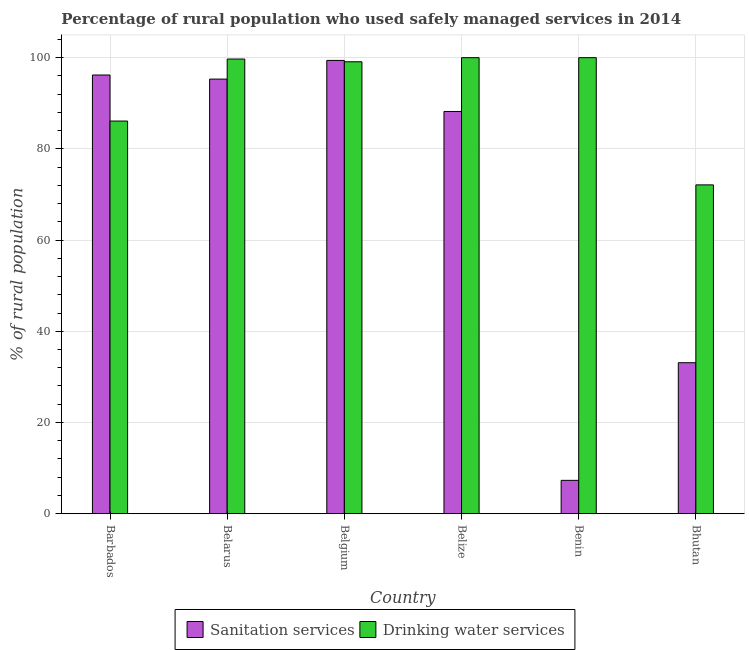How many groups of bars are there?
Ensure brevity in your answer.  6. Are the number of bars per tick equal to the number of legend labels?
Offer a terse response. Yes. How many bars are there on the 1st tick from the left?
Keep it short and to the point. 2. What is the label of the 1st group of bars from the left?
Your response must be concise. Barbados. In how many cases, is the number of bars for a given country not equal to the number of legend labels?
Offer a terse response. 0. What is the percentage of rural population who used sanitation services in Barbados?
Your answer should be compact. 96.2. Across all countries, what is the maximum percentage of rural population who used sanitation services?
Your answer should be very brief. 99.4. In which country was the percentage of rural population who used drinking water services maximum?
Your answer should be compact. Belize. In which country was the percentage of rural population who used sanitation services minimum?
Your response must be concise. Benin. What is the total percentage of rural population who used sanitation services in the graph?
Give a very brief answer. 419.5. What is the difference between the percentage of rural population who used drinking water services in Belarus and that in Benin?
Ensure brevity in your answer.  -0.3. What is the difference between the percentage of rural population who used drinking water services in Bhutan and the percentage of rural population who used sanitation services in Barbados?
Give a very brief answer. -24.1. What is the average percentage of rural population who used drinking water services per country?
Your answer should be very brief. 92.83. What is the difference between the percentage of rural population who used sanitation services and percentage of rural population who used drinking water services in Barbados?
Offer a terse response. 10.1. What is the ratio of the percentage of rural population who used sanitation services in Belgium to that in Benin?
Make the answer very short. 13.62. Is the percentage of rural population who used drinking water services in Belgium less than that in Belize?
Ensure brevity in your answer.  Yes. Is the difference between the percentage of rural population who used drinking water services in Belize and Bhutan greater than the difference between the percentage of rural population who used sanitation services in Belize and Bhutan?
Your answer should be compact. No. What is the difference between the highest and the second highest percentage of rural population who used sanitation services?
Give a very brief answer. 3.2. What is the difference between the highest and the lowest percentage of rural population who used drinking water services?
Your answer should be compact. 27.9. What does the 2nd bar from the left in Bhutan represents?
Your answer should be compact. Drinking water services. What does the 1st bar from the right in Barbados represents?
Your response must be concise. Drinking water services. How many bars are there?
Offer a very short reply. 12. Are the values on the major ticks of Y-axis written in scientific E-notation?
Offer a very short reply. No. Does the graph contain any zero values?
Offer a terse response. No. Does the graph contain grids?
Provide a short and direct response. Yes. Where does the legend appear in the graph?
Offer a terse response. Bottom center. How are the legend labels stacked?
Your answer should be compact. Horizontal. What is the title of the graph?
Your response must be concise. Percentage of rural population who used safely managed services in 2014. Does "constant 2005 US$" appear as one of the legend labels in the graph?
Offer a terse response. No. What is the label or title of the Y-axis?
Give a very brief answer. % of rural population. What is the % of rural population in Sanitation services in Barbados?
Keep it short and to the point. 96.2. What is the % of rural population of Drinking water services in Barbados?
Make the answer very short. 86.1. What is the % of rural population in Sanitation services in Belarus?
Your response must be concise. 95.3. What is the % of rural population of Drinking water services in Belarus?
Your answer should be compact. 99.7. What is the % of rural population of Sanitation services in Belgium?
Give a very brief answer. 99.4. What is the % of rural population of Drinking water services in Belgium?
Provide a short and direct response. 99.1. What is the % of rural population in Sanitation services in Belize?
Offer a very short reply. 88.2. What is the % of rural population of Drinking water services in Belize?
Give a very brief answer. 100. What is the % of rural population of Sanitation services in Benin?
Offer a terse response. 7.3. What is the % of rural population in Drinking water services in Benin?
Offer a terse response. 100. What is the % of rural population in Sanitation services in Bhutan?
Provide a succinct answer. 33.1. What is the % of rural population in Drinking water services in Bhutan?
Offer a terse response. 72.1. Across all countries, what is the maximum % of rural population in Sanitation services?
Give a very brief answer. 99.4. Across all countries, what is the minimum % of rural population in Drinking water services?
Provide a short and direct response. 72.1. What is the total % of rural population in Sanitation services in the graph?
Keep it short and to the point. 419.5. What is the total % of rural population in Drinking water services in the graph?
Give a very brief answer. 557. What is the difference between the % of rural population in Sanitation services in Barbados and that in Belarus?
Offer a terse response. 0.9. What is the difference between the % of rural population in Sanitation services in Barbados and that in Belgium?
Your response must be concise. -3.2. What is the difference between the % of rural population of Drinking water services in Barbados and that in Belgium?
Provide a succinct answer. -13. What is the difference between the % of rural population of Drinking water services in Barbados and that in Belize?
Keep it short and to the point. -13.9. What is the difference between the % of rural population of Sanitation services in Barbados and that in Benin?
Your answer should be compact. 88.9. What is the difference between the % of rural population of Sanitation services in Barbados and that in Bhutan?
Your answer should be very brief. 63.1. What is the difference between the % of rural population in Sanitation services in Belarus and that in Belize?
Make the answer very short. 7.1. What is the difference between the % of rural population in Drinking water services in Belarus and that in Belize?
Provide a short and direct response. -0.3. What is the difference between the % of rural population of Sanitation services in Belarus and that in Bhutan?
Ensure brevity in your answer.  62.2. What is the difference between the % of rural population in Drinking water services in Belarus and that in Bhutan?
Give a very brief answer. 27.6. What is the difference between the % of rural population in Sanitation services in Belgium and that in Belize?
Give a very brief answer. 11.2. What is the difference between the % of rural population of Sanitation services in Belgium and that in Benin?
Make the answer very short. 92.1. What is the difference between the % of rural population in Drinking water services in Belgium and that in Benin?
Offer a terse response. -0.9. What is the difference between the % of rural population of Sanitation services in Belgium and that in Bhutan?
Provide a short and direct response. 66.3. What is the difference between the % of rural population in Drinking water services in Belgium and that in Bhutan?
Keep it short and to the point. 27. What is the difference between the % of rural population of Sanitation services in Belize and that in Benin?
Provide a short and direct response. 80.9. What is the difference between the % of rural population of Drinking water services in Belize and that in Benin?
Make the answer very short. 0. What is the difference between the % of rural population in Sanitation services in Belize and that in Bhutan?
Your response must be concise. 55.1. What is the difference between the % of rural population in Drinking water services in Belize and that in Bhutan?
Provide a short and direct response. 27.9. What is the difference between the % of rural population in Sanitation services in Benin and that in Bhutan?
Ensure brevity in your answer.  -25.8. What is the difference between the % of rural population in Drinking water services in Benin and that in Bhutan?
Provide a short and direct response. 27.9. What is the difference between the % of rural population in Sanitation services in Barbados and the % of rural population in Drinking water services in Belarus?
Give a very brief answer. -3.5. What is the difference between the % of rural population of Sanitation services in Barbados and the % of rural population of Drinking water services in Benin?
Make the answer very short. -3.8. What is the difference between the % of rural population of Sanitation services in Barbados and the % of rural population of Drinking water services in Bhutan?
Keep it short and to the point. 24.1. What is the difference between the % of rural population in Sanitation services in Belarus and the % of rural population in Drinking water services in Benin?
Provide a succinct answer. -4.7. What is the difference between the % of rural population in Sanitation services in Belarus and the % of rural population in Drinking water services in Bhutan?
Your response must be concise. 23.2. What is the difference between the % of rural population of Sanitation services in Belgium and the % of rural population of Drinking water services in Belize?
Offer a terse response. -0.6. What is the difference between the % of rural population of Sanitation services in Belgium and the % of rural population of Drinking water services in Benin?
Offer a very short reply. -0.6. What is the difference between the % of rural population of Sanitation services in Belgium and the % of rural population of Drinking water services in Bhutan?
Your answer should be compact. 27.3. What is the difference between the % of rural population of Sanitation services in Belize and the % of rural population of Drinking water services in Benin?
Ensure brevity in your answer.  -11.8. What is the difference between the % of rural population of Sanitation services in Benin and the % of rural population of Drinking water services in Bhutan?
Keep it short and to the point. -64.8. What is the average % of rural population of Sanitation services per country?
Your answer should be very brief. 69.92. What is the average % of rural population in Drinking water services per country?
Keep it short and to the point. 92.83. What is the difference between the % of rural population in Sanitation services and % of rural population in Drinking water services in Barbados?
Give a very brief answer. 10.1. What is the difference between the % of rural population in Sanitation services and % of rural population in Drinking water services in Belize?
Provide a succinct answer. -11.8. What is the difference between the % of rural population in Sanitation services and % of rural population in Drinking water services in Benin?
Your answer should be compact. -92.7. What is the difference between the % of rural population of Sanitation services and % of rural population of Drinking water services in Bhutan?
Your answer should be very brief. -39. What is the ratio of the % of rural population of Sanitation services in Barbados to that in Belarus?
Keep it short and to the point. 1.01. What is the ratio of the % of rural population of Drinking water services in Barbados to that in Belarus?
Make the answer very short. 0.86. What is the ratio of the % of rural population in Sanitation services in Barbados to that in Belgium?
Give a very brief answer. 0.97. What is the ratio of the % of rural population in Drinking water services in Barbados to that in Belgium?
Your response must be concise. 0.87. What is the ratio of the % of rural population in Sanitation services in Barbados to that in Belize?
Provide a short and direct response. 1.09. What is the ratio of the % of rural population in Drinking water services in Barbados to that in Belize?
Your response must be concise. 0.86. What is the ratio of the % of rural population of Sanitation services in Barbados to that in Benin?
Make the answer very short. 13.18. What is the ratio of the % of rural population of Drinking water services in Barbados to that in Benin?
Offer a terse response. 0.86. What is the ratio of the % of rural population in Sanitation services in Barbados to that in Bhutan?
Your response must be concise. 2.91. What is the ratio of the % of rural population in Drinking water services in Barbados to that in Bhutan?
Give a very brief answer. 1.19. What is the ratio of the % of rural population in Sanitation services in Belarus to that in Belgium?
Ensure brevity in your answer.  0.96. What is the ratio of the % of rural population of Drinking water services in Belarus to that in Belgium?
Your response must be concise. 1.01. What is the ratio of the % of rural population of Sanitation services in Belarus to that in Belize?
Your answer should be very brief. 1.08. What is the ratio of the % of rural population in Sanitation services in Belarus to that in Benin?
Keep it short and to the point. 13.05. What is the ratio of the % of rural population in Drinking water services in Belarus to that in Benin?
Your answer should be compact. 1. What is the ratio of the % of rural population in Sanitation services in Belarus to that in Bhutan?
Provide a short and direct response. 2.88. What is the ratio of the % of rural population of Drinking water services in Belarus to that in Bhutan?
Offer a very short reply. 1.38. What is the ratio of the % of rural population of Sanitation services in Belgium to that in Belize?
Offer a very short reply. 1.13. What is the ratio of the % of rural population of Drinking water services in Belgium to that in Belize?
Offer a very short reply. 0.99. What is the ratio of the % of rural population in Sanitation services in Belgium to that in Benin?
Make the answer very short. 13.62. What is the ratio of the % of rural population of Sanitation services in Belgium to that in Bhutan?
Your answer should be compact. 3. What is the ratio of the % of rural population in Drinking water services in Belgium to that in Bhutan?
Make the answer very short. 1.37. What is the ratio of the % of rural population in Sanitation services in Belize to that in Benin?
Ensure brevity in your answer.  12.08. What is the ratio of the % of rural population of Drinking water services in Belize to that in Benin?
Your response must be concise. 1. What is the ratio of the % of rural population in Sanitation services in Belize to that in Bhutan?
Make the answer very short. 2.66. What is the ratio of the % of rural population of Drinking water services in Belize to that in Bhutan?
Offer a terse response. 1.39. What is the ratio of the % of rural population in Sanitation services in Benin to that in Bhutan?
Offer a terse response. 0.22. What is the ratio of the % of rural population in Drinking water services in Benin to that in Bhutan?
Provide a succinct answer. 1.39. What is the difference between the highest and the second highest % of rural population in Sanitation services?
Your response must be concise. 3.2. What is the difference between the highest and the lowest % of rural population in Sanitation services?
Give a very brief answer. 92.1. What is the difference between the highest and the lowest % of rural population in Drinking water services?
Ensure brevity in your answer.  27.9. 